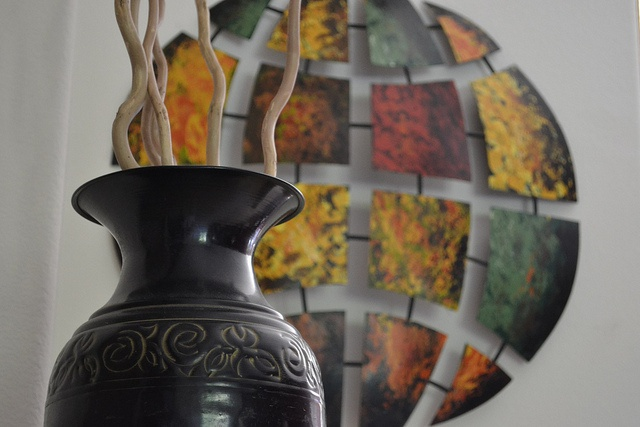Describe the objects in this image and their specific colors. I can see a vase in gray, black, and darkgray tones in this image. 